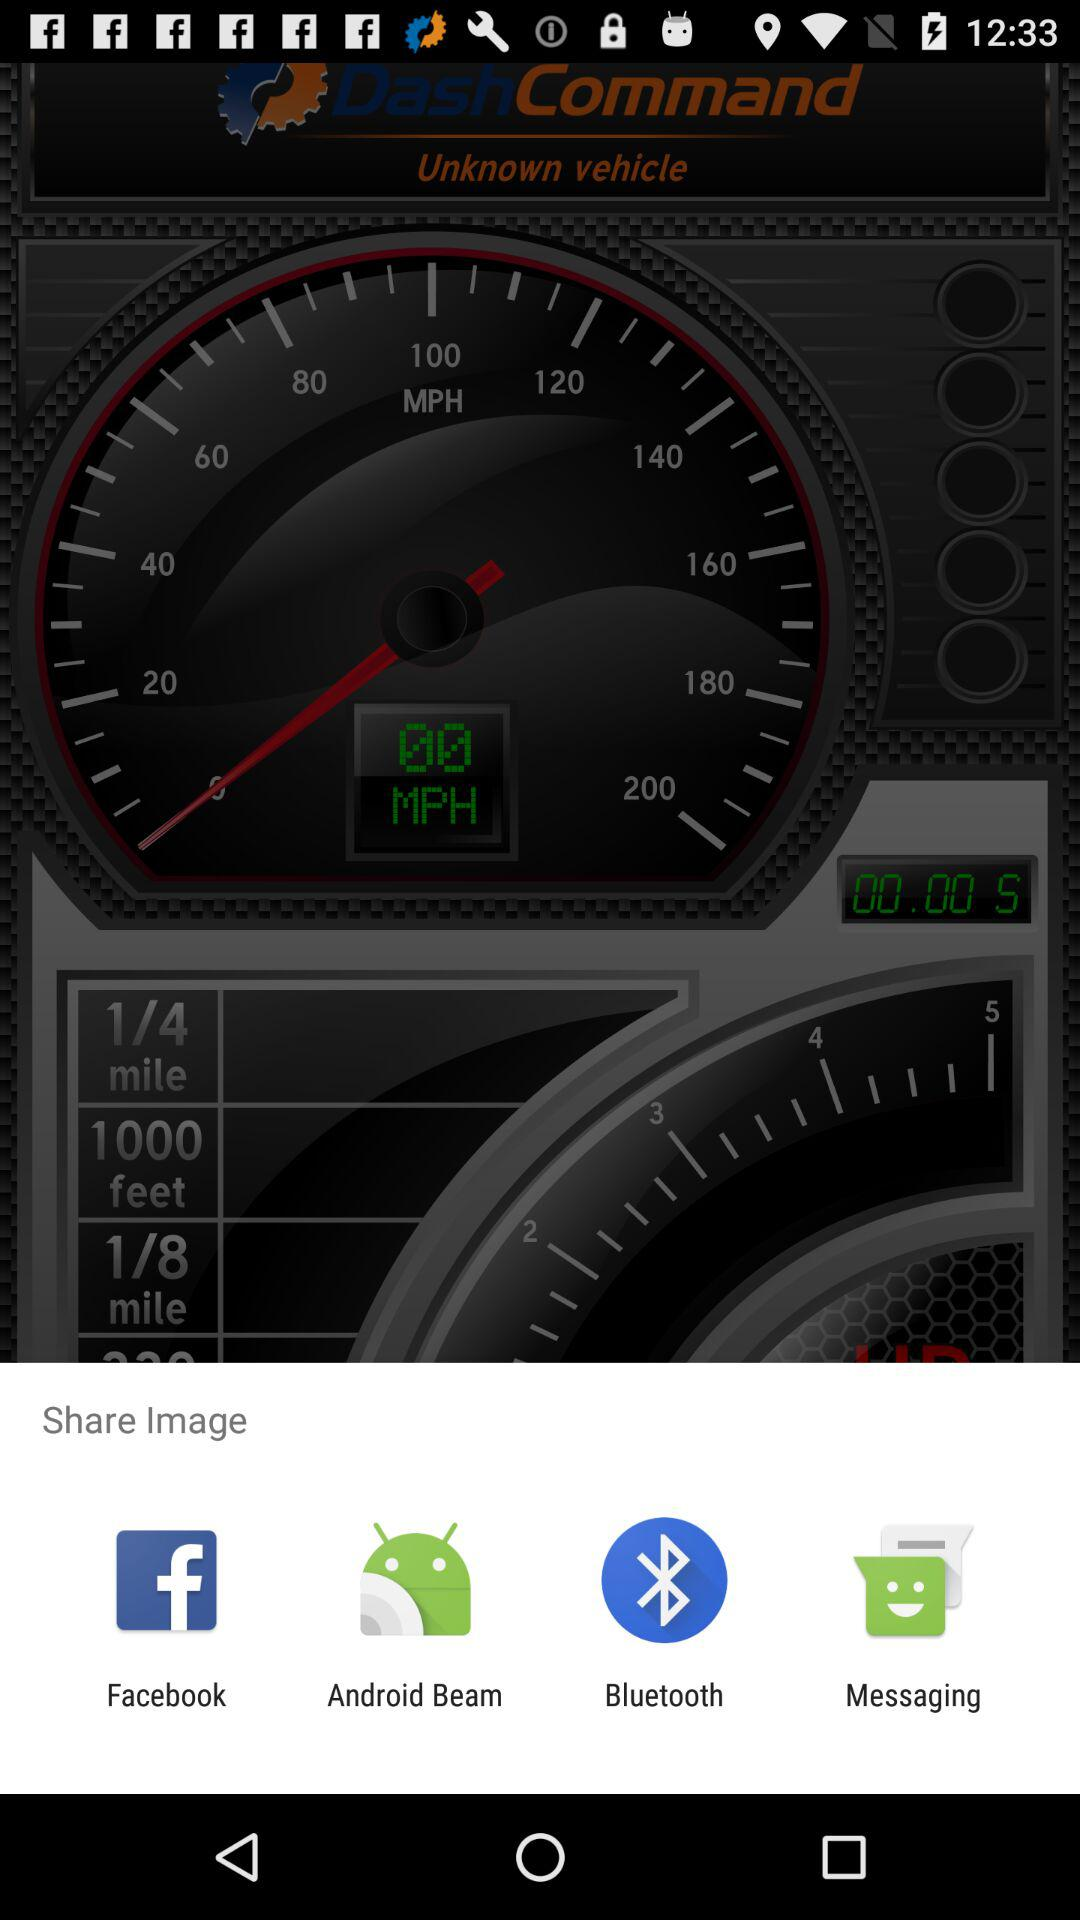What are the different mediums to share? The different mediums are "Facebook", "Android Beam", "Bluetooth" and "Messaging". 